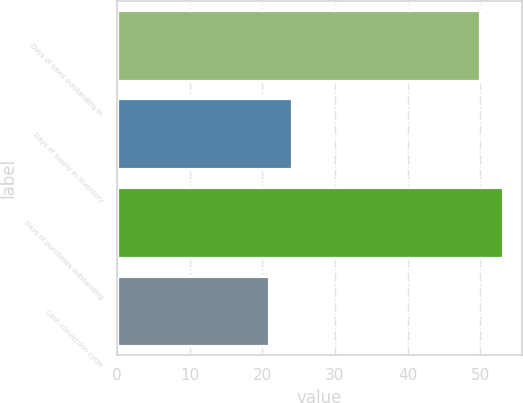Convert chart. <chart><loc_0><loc_0><loc_500><loc_500><bar_chart><fcel>Days of sales outstanding in<fcel>Days of supply in inventory<fcel>Days of purchases outstanding<fcel>Cash conversion cycle<nl><fcel>50<fcel>24.1<fcel>53.1<fcel>21<nl></chart> 